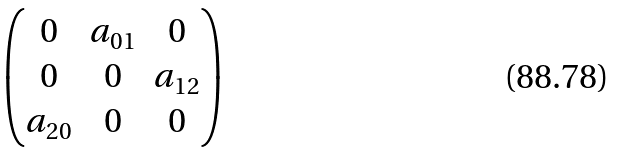<formula> <loc_0><loc_0><loc_500><loc_500>\begin{pmatrix} 0 & a _ { 0 1 } & 0 \\ 0 & 0 & a _ { 1 2 } \\ a _ { 2 0 } & 0 & 0 \end{pmatrix}</formula> 